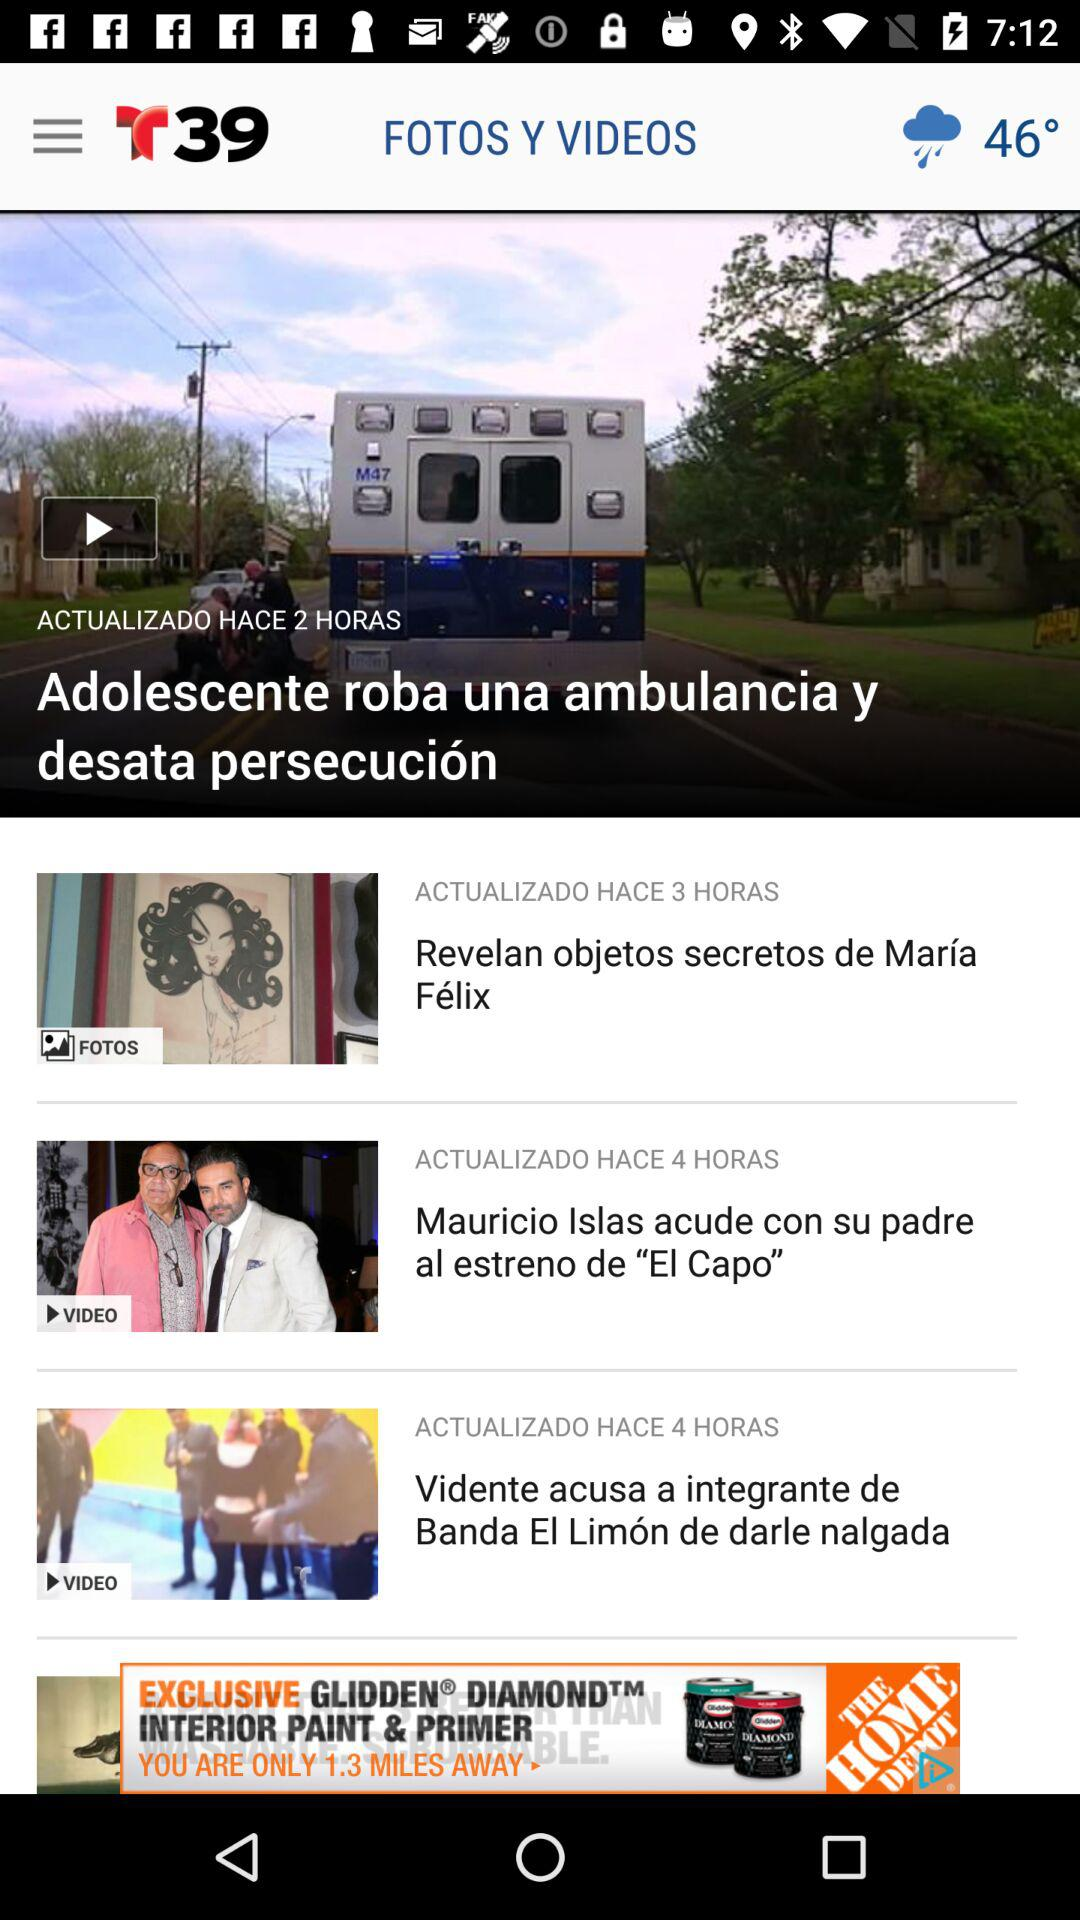How many more hours ago was the third item updated than the first item?
Answer the question using a single word or phrase. 1 